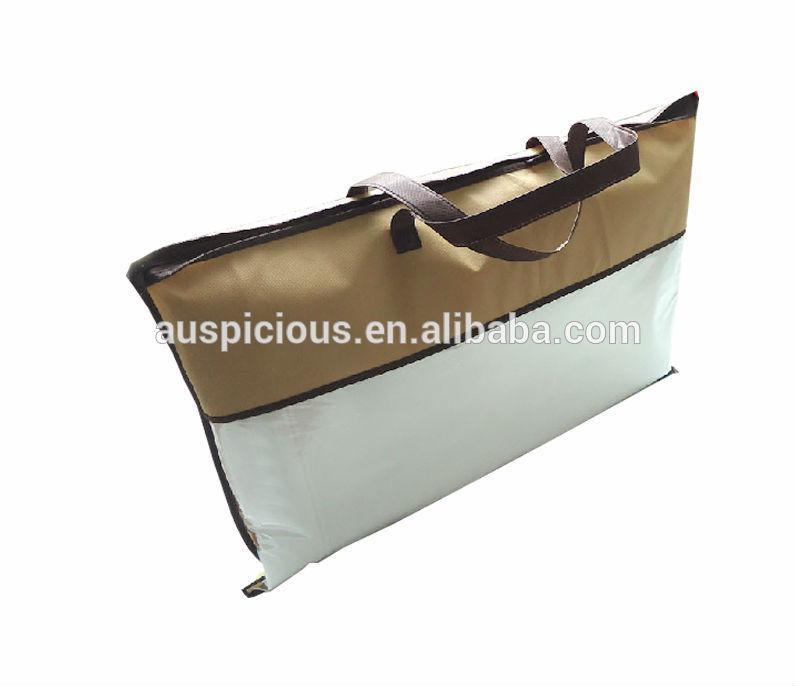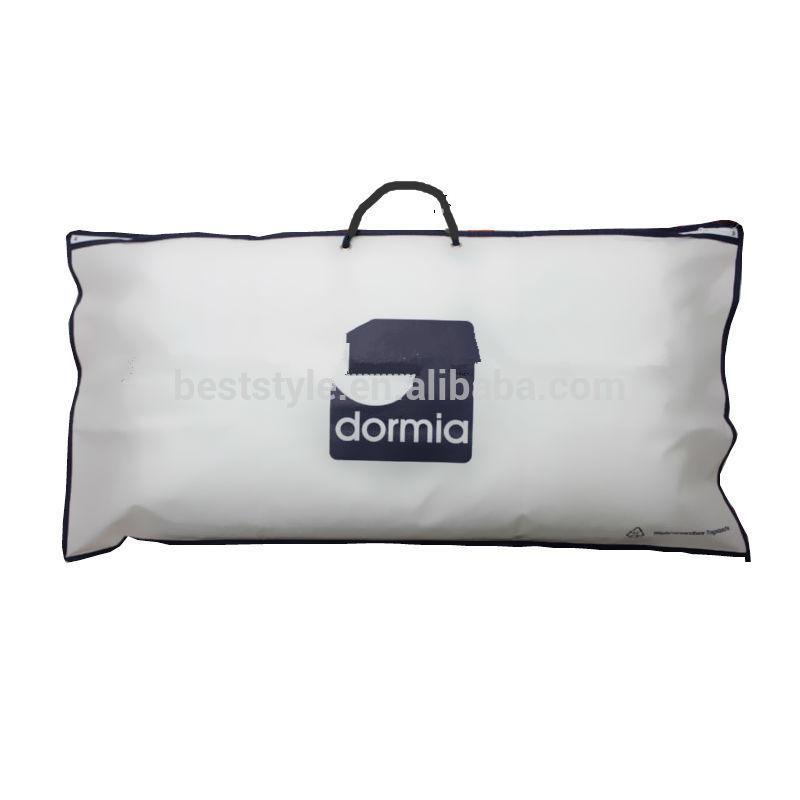The first image is the image on the left, the second image is the image on the right. Assess this claim about the two images: "In at least one image there is a pillow in a plastic zip bag that has gold plastic on the top fourth.". Correct or not? Answer yes or no. Yes. The first image is the image on the left, the second image is the image on the right. For the images displayed, is the sentence "Each image shows a pillow bag with at least one handle, and one image displays a bag head-on, while the other displays a bag at an angle." factually correct? Answer yes or no. Yes. 